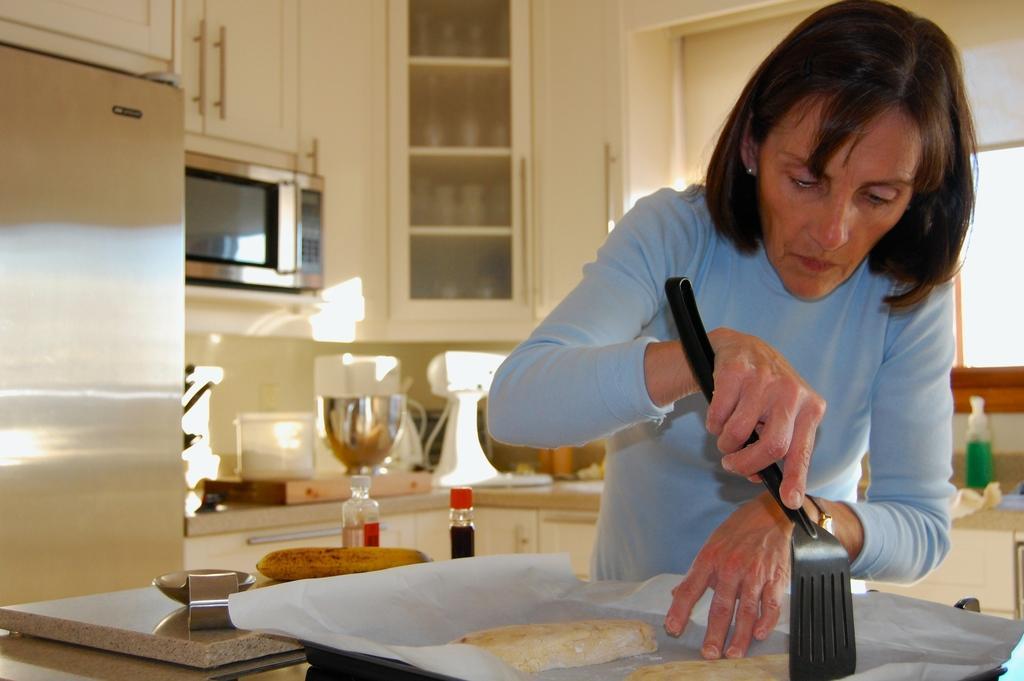In one or two sentences, can you explain what this image depicts? In this image we can see a person holding a spatula, there is a tray with food items and a paper, there are two bottles and few other objects on the table and in the background there are few objects on the counter top, there are cupboards, an oven and a fridge in the background. 